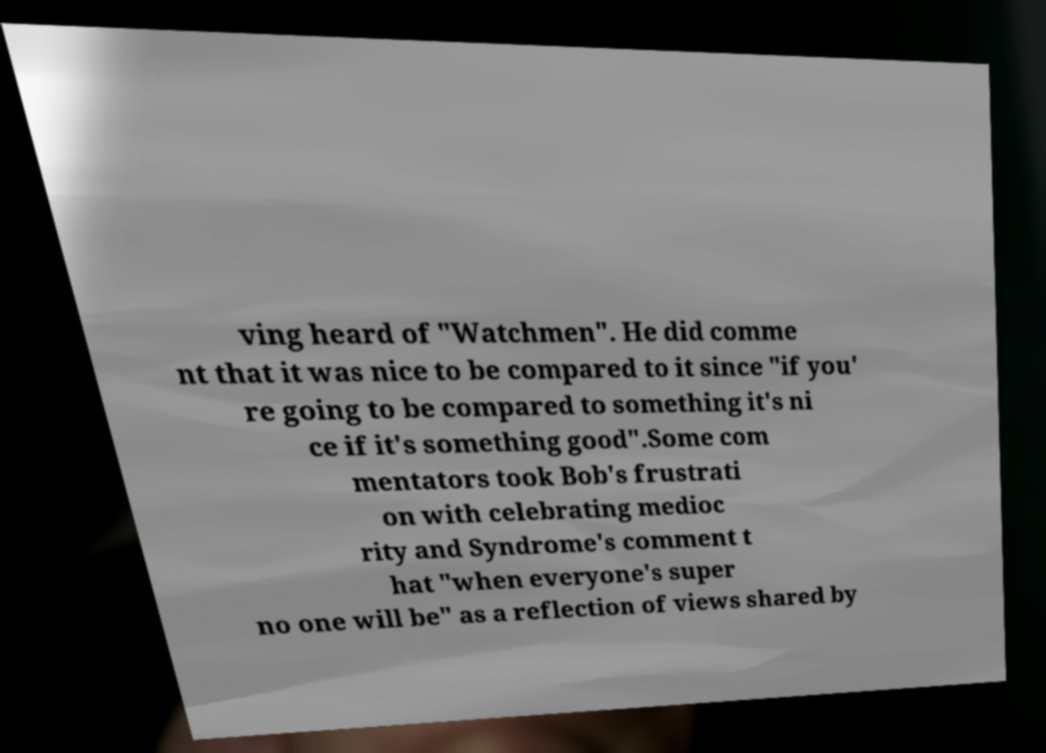Please read and relay the text visible in this image. What does it say? ving heard of "Watchmen". He did comme nt that it was nice to be compared to it since "if you' re going to be compared to something it's ni ce if it's something good".Some com mentators took Bob's frustrati on with celebrating medioc rity and Syndrome's comment t hat "when everyone's super no one will be" as a reflection of views shared by 